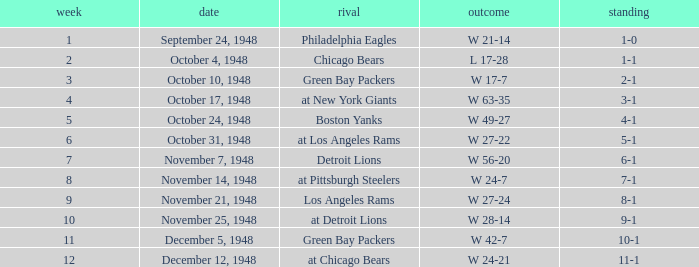What was the record for December 5, 1948? 10-1. 